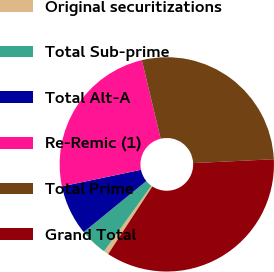<chart> <loc_0><loc_0><loc_500><loc_500><pie_chart><fcel>Original securitizations<fcel>Total Sub-prime<fcel>Total Alt-A<fcel>Re-Remic (1)<fcel>Total Prime<fcel>Grand Total<nl><fcel>0.74%<fcel>4.17%<fcel>7.59%<fcel>24.55%<fcel>27.98%<fcel>34.97%<nl></chart> 